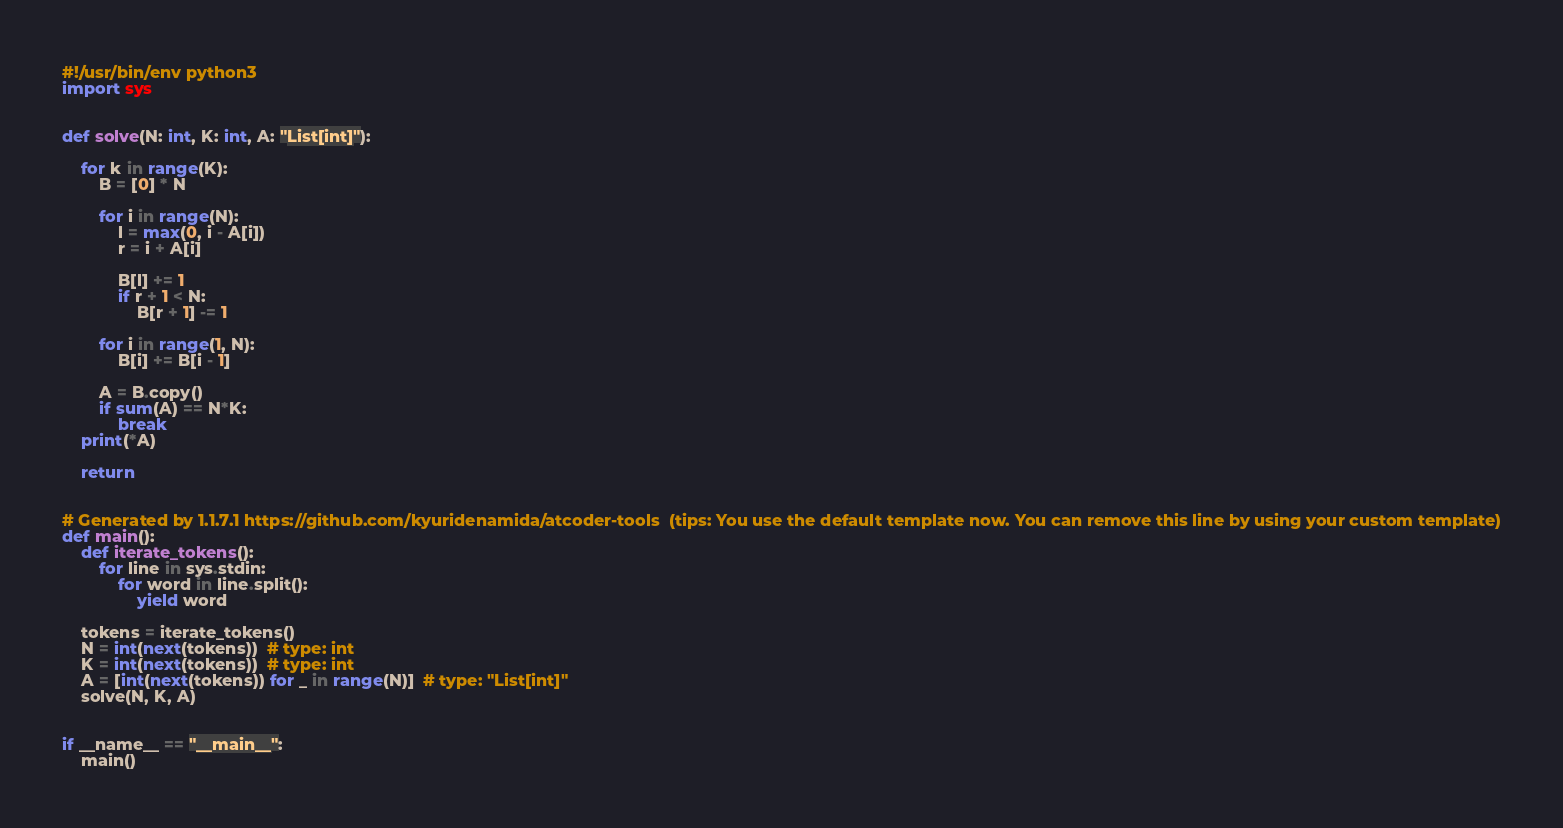<code> <loc_0><loc_0><loc_500><loc_500><_Python_>#!/usr/bin/env python3
import sys


def solve(N: int, K: int, A: "List[int]"):

    for k in range(K):
        B = [0] * N

        for i in range(N):
            l = max(0, i - A[i])
            r = i + A[i]

            B[l] += 1
            if r + 1 < N:
                B[r + 1] -= 1

        for i in range(1, N):
            B[i] += B[i - 1]

        A = B.copy()
        if sum(A) == N*K:
            break
    print(*A)

    return


# Generated by 1.1.7.1 https://github.com/kyuridenamida/atcoder-tools  (tips: You use the default template now. You can remove this line by using your custom template)
def main():
    def iterate_tokens():
        for line in sys.stdin:
            for word in line.split():
                yield word

    tokens = iterate_tokens()
    N = int(next(tokens))  # type: int
    K = int(next(tokens))  # type: int
    A = [int(next(tokens)) for _ in range(N)]  # type: "List[int]"
    solve(N, K, A)


if __name__ == "__main__":
    main()
</code> 